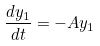<formula> <loc_0><loc_0><loc_500><loc_500>\frac { d y _ { 1 } } { d t } = - A y _ { 1 }</formula> 